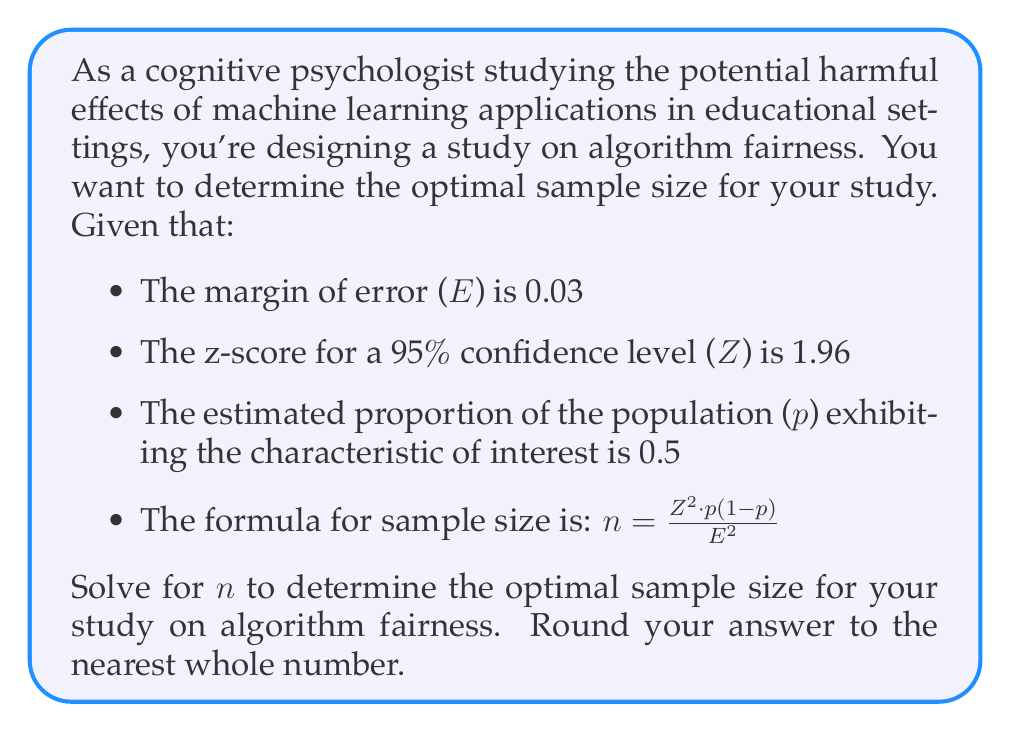Teach me how to tackle this problem. To solve this problem, we'll use the given formula and substitute the known values:

$n = \frac{Z^2 * p(1-p)}{E^2}$

Where:
$Z = 1.96$ (z-score for 95% confidence level)
$p = 0.5$ (estimated proportion)
$E = 0.03$ (margin of error)

Let's substitute these values into the formula:

$n = \frac{(1.96)^2 * 0.5(1-0.5)}{(0.03)^2}$

Now, let's solve step by step:

1. Calculate $Z^2$:
   $1.96^2 = 3.8416$

2. Calculate $p(1-p)$:
   $0.5(1-0.5) = 0.5 * 0.5 = 0.25$

3. Calculate $E^2$:
   $0.03^2 = 0.0009$

4. Substitute these values into the numerator and denominator:
   $n = \frac{3.8416 * 0.25}{0.0009}$

5. Multiply the numerator:
   $n = \frac{0.9604}{0.0009}$

6. Divide:
   $n = 1067.11...$

7. Round to the nearest whole number:
   $n ≈ 1067$

Therefore, the optimal sample size for your study on algorithm fairness is 1067 participants.
Answer: 1067 